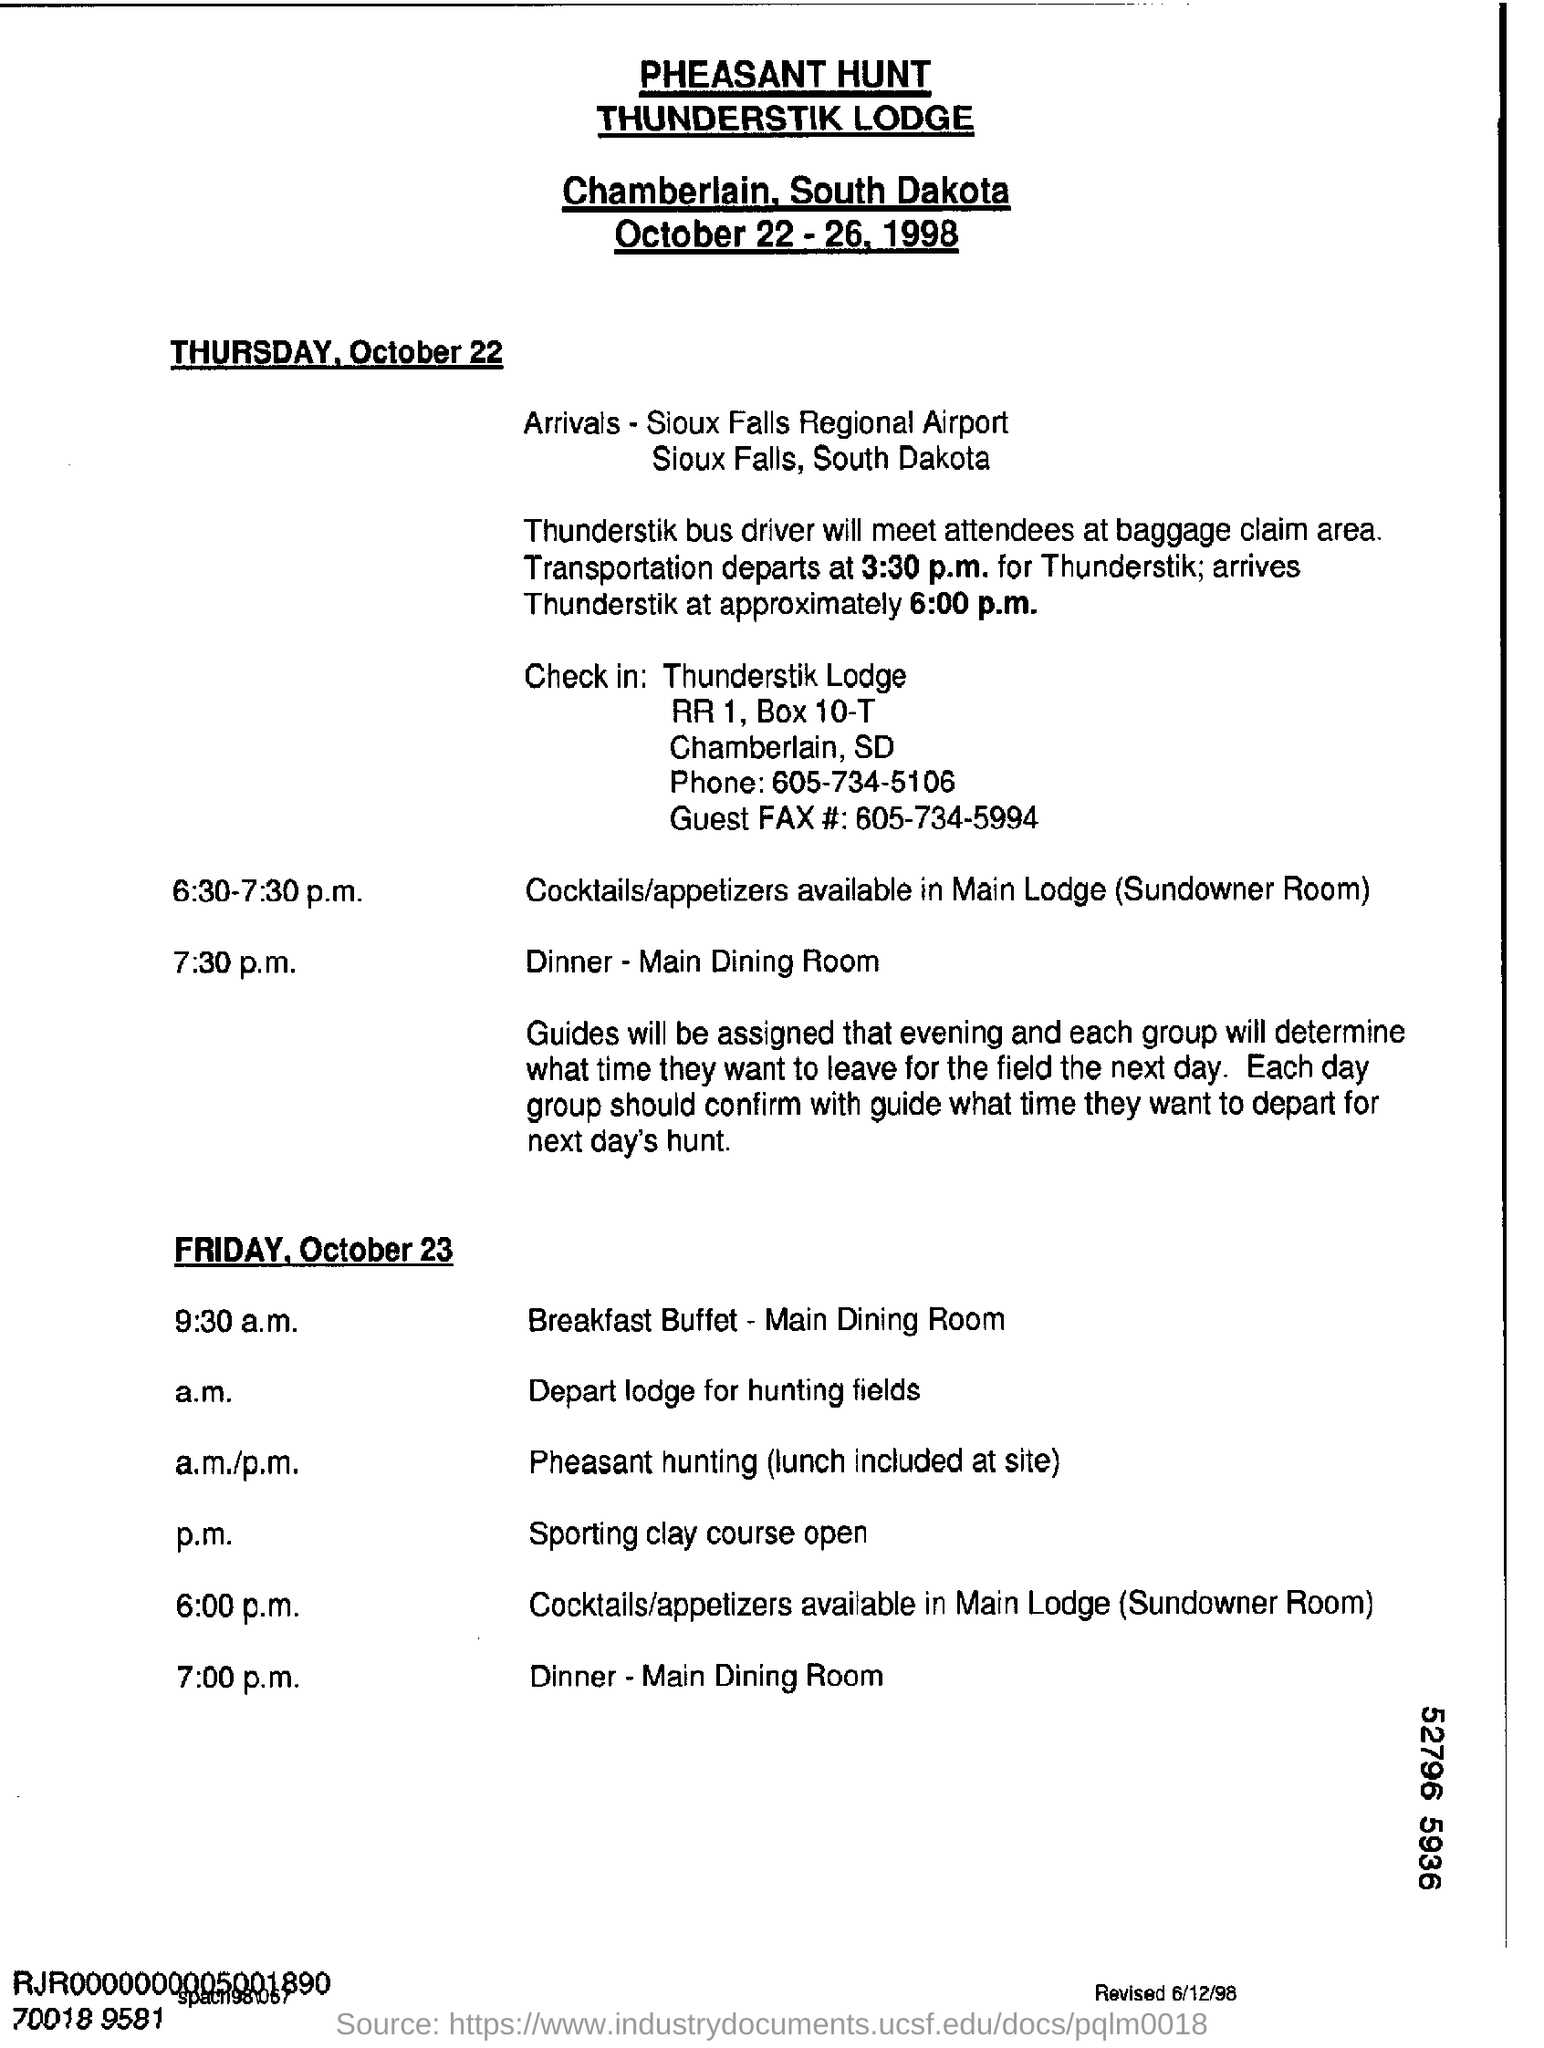Specify some key components in this picture. The dinner is held in the main dining room. The train is expected to arrive at Thunderstik at approximately 6:00 p.m. Chamberlain, South Dakota is the location of the thing. The transportation is scheduled to depart at 3:30 p.m. I hereby declare that the name of the Lodge is Thunderstik Lodge. 